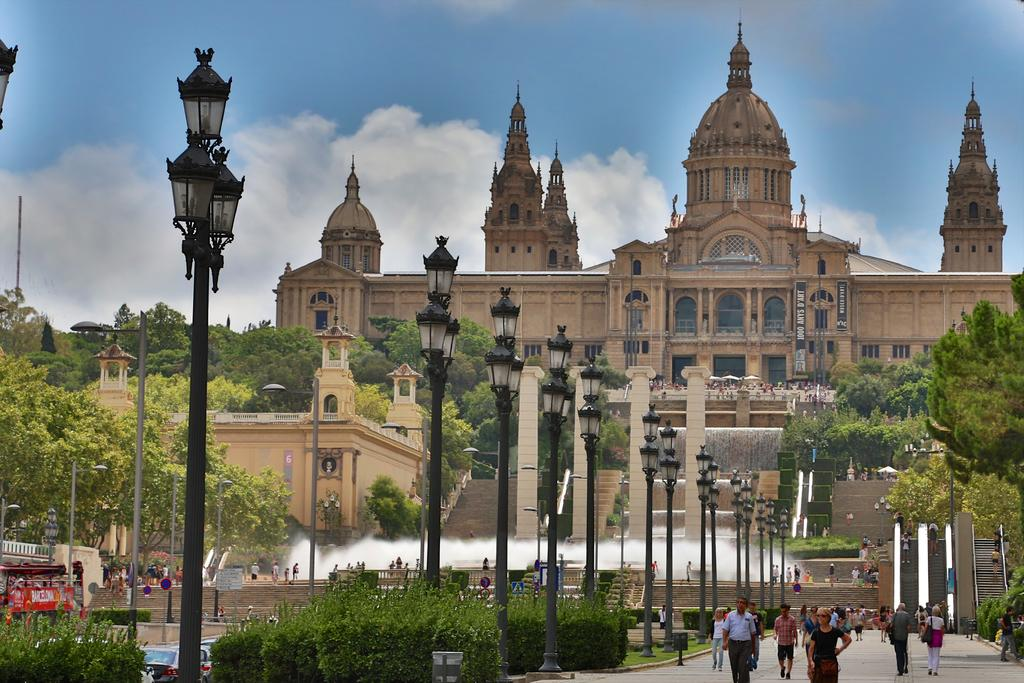What type of structures can be seen in the image? There are buildings in the image. What are the vertical objects in the image? There are poles in the image. What type of vegetation is present in the image? There are plants and trees in the image. What can be seen illuminating the area in the image? There are lights in the image. What type of surface is visible in the image? There are boards in the image. What type of transportation is present in the image? There are vehicles in the image. Are there any living beings in the image? Yes, there are people in the image. What is visible in the background of the image? The sky is visible in the background of the image, with clouds present. Where is the roof located in the image? There is no specific roof mentioned in the provided facts, and therefore it cannot be located in the image. What type of lamp is hanging from the shelf in the image? There is no shelf or lamp present in the image. 